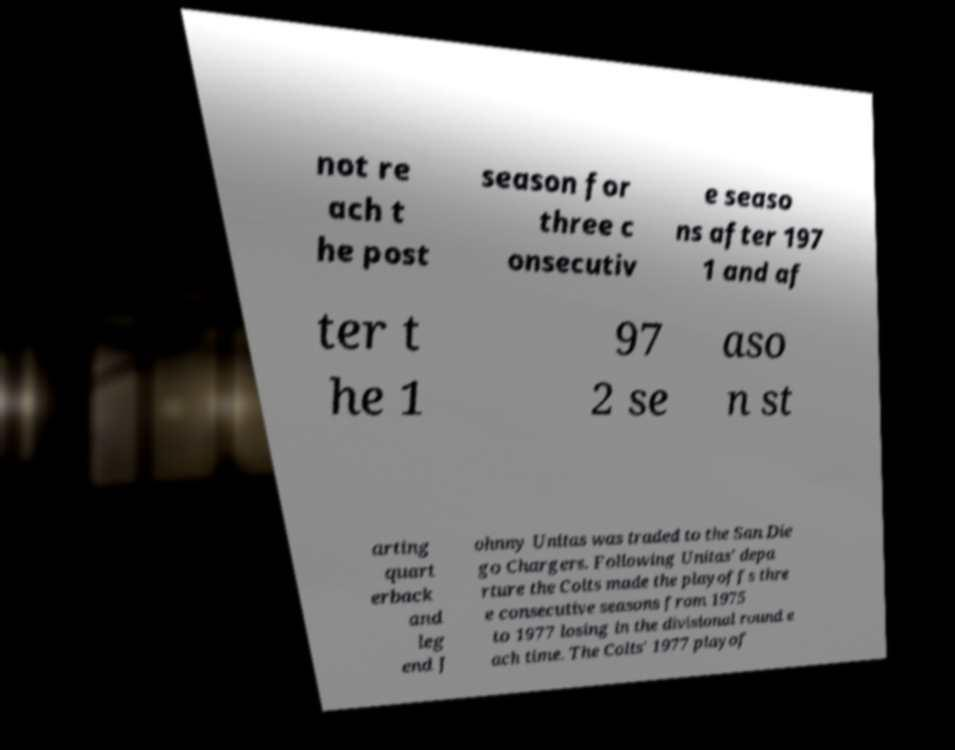What messages or text are displayed in this image? I need them in a readable, typed format. not re ach t he post season for three c onsecutiv e seaso ns after 197 1 and af ter t he 1 97 2 se aso n st arting quart erback and leg end J ohnny Unitas was traded to the San Die go Chargers. Following Unitas' depa rture the Colts made the playoffs thre e consecutive seasons from 1975 to 1977 losing in the divisional round e ach time. The Colts' 1977 playof 